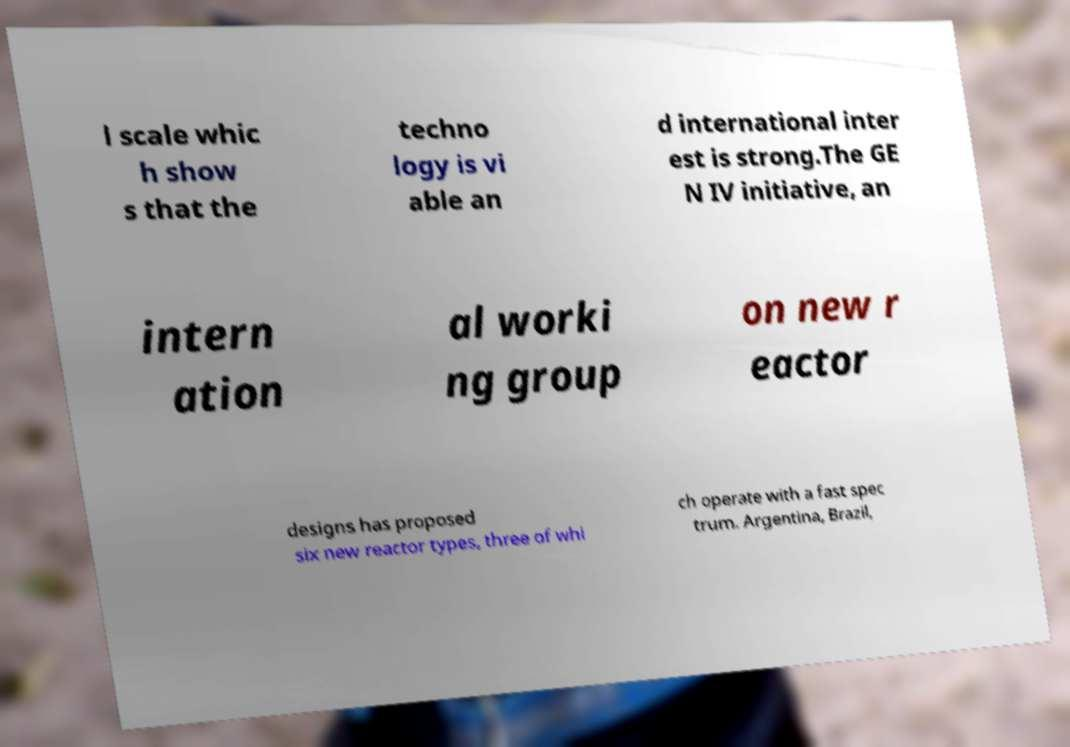Could you assist in decoding the text presented in this image and type it out clearly? l scale whic h show s that the techno logy is vi able an d international inter est is strong.The GE N IV initiative, an intern ation al worki ng group on new r eactor designs has proposed six new reactor types, three of whi ch operate with a fast spec trum. Argentina, Brazil, 